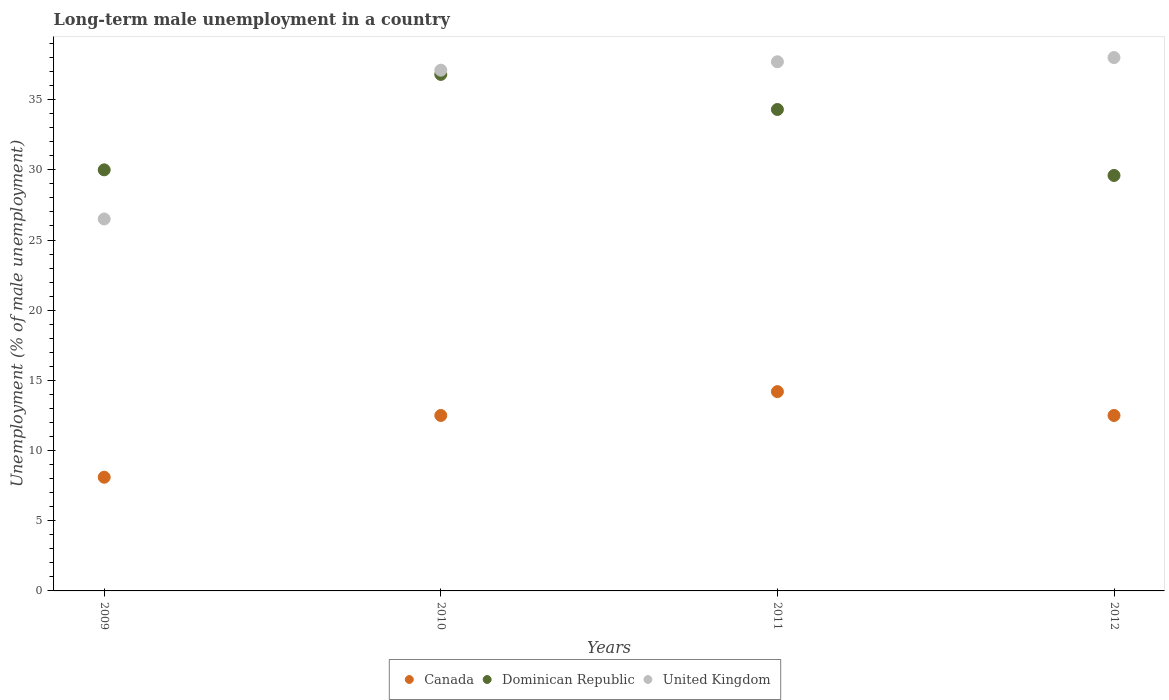How many different coloured dotlines are there?
Offer a very short reply. 3. Is the number of dotlines equal to the number of legend labels?
Provide a succinct answer. Yes. What is the percentage of long-term unemployed male population in Dominican Republic in 2011?
Keep it short and to the point. 34.3. Across all years, what is the minimum percentage of long-term unemployed male population in Dominican Republic?
Your answer should be very brief. 29.6. What is the total percentage of long-term unemployed male population in Dominican Republic in the graph?
Provide a short and direct response. 130.7. What is the difference between the percentage of long-term unemployed male population in Canada in 2009 and that in 2011?
Offer a very short reply. -6.1. What is the difference between the percentage of long-term unemployed male population in Dominican Republic in 2012 and the percentage of long-term unemployed male population in United Kingdom in 2009?
Offer a terse response. 3.1. What is the average percentage of long-term unemployed male population in Dominican Republic per year?
Your answer should be compact. 32.67. In the year 2012, what is the difference between the percentage of long-term unemployed male population in Dominican Republic and percentage of long-term unemployed male population in Canada?
Make the answer very short. 17.1. What is the ratio of the percentage of long-term unemployed male population in Canada in 2009 to that in 2011?
Provide a short and direct response. 0.57. Is the percentage of long-term unemployed male population in Dominican Republic in 2010 less than that in 2011?
Make the answer very short. No. What is the difference between the highest and the second highest percentage of long-term unemployed male population in Canada?
Keep it short and to the point. 1.7. What is the difference between the highest and the lowest percentage of long-term unemployed male population in United Kingdom?
Offer a terse response. 11.5. In how many years, is the percentage of long-term unemployed male population in United Kingdom greater than the average percentage of long-term unemployed male population in United Kingdom taken over all years?
Keep it short and to the point. 3. Is it the case that in every year, the sum of the percentage of long-term unemployed male population in Dominican Republic and percentage of long-term unemployed male population in Canada  is greater than the percentage of long-term unemployed male population in United Kingdom?
Your response must be concise. Yes. Does the percentage of long-term unemployed male population in Canada monotonically increase over the years?
Offer a very short reply. No. Is the percentage of long-term unemployed male population in Canada strictly greater than the percentage of long-term unemployed male population in Dominican Republic over the years?
Provide a succinct answer. No. Is the percentage of long-term unemployed male population in United Kingdom strictly less than the percentage of long-term unemployed male population in Canada over the years?
Make the answer very short. No. How many dotlines are there?
Ensure brevity in your answer.  3. How many years are there in the graph?
Offer a terse response. 4. What is the difference between two consecutive major ticks on the Y-axis?
Give a very brief answer. 5. Does the graph contain any zero values?
Ensure brevity in your answer.  No. Does the graph contain grids?
Provide a succinct answer. No. What is the title of the graph?
Offer a terse response. Long-term male unemployment in a country. Does "East Asia (all income levels)" appear as one of the legend labels in the graph?
Make the answer very short. No. What is the label or title of the Y-axis?
Keep it short and to the point. Unemployment (% of male unemployment). What is the Unemployment (% of male unemployment) of Canada in 2009?
Keep it short and to the point. 8.1. What is the Unemployment (% of male unemployment) in Dominican Republic in 2010?
Offer a terse response. 36.8. What is the Unemployment (% of male unemployment) of United Kingdom in 2010?
Make the answer very short. 37.1. What is the Unemployment (% of male unemployment) in Canada in 2011?
Your answer should be very brief. 14.2. What is the Unemployment (% of male unemployment) of Dominican Republic in 2011?
Make the answer very short. 34.3. What is the Unemployment (% of male unemployment) of United Kingdom in 2011?
Provide a short and direct response. 37.7. What is the Unemployment (% of male unemployment) of Canada in 2012?
Your answer should be very brief. 12.5. What is the Unemployment (% of male unemployment) in Dominican Republic in 2012?
Provide a short and direct response. 29.6. What is the Unemployment (% of male unemployment) in United Kingdom in 2012?
Provide a short and direct response. 38. Across all years, what is the maximum Unemployment (% of male unemployment) of Canada?
Your response must be concise. 14.2. Across all years, what is the maximum Unemployment (% of male unemployment) in Dominican Republic?
Your answer should be compact. 36.8. Across all years, what is the minimum Unemployment (% of male unemployment) of Canada?
Offer a very short reply. 8.1. Across all years, what is the minimum Unemployment (% of male unemployment) in Dominican Republic?
Your answer should be compact. 29.6. Across all years, what is the minimum Unemployment (% of male unemployment) of United Kingdom?
Offer a very short reply. 26.5. What is the total Unemployment (% of male unemployment) of Canada in the graph?
Your response must be concise. 47.3. What is the total Unemployment (% of male unemployment) of Dominican Republic in the graph?
Ensure brevity in your answer.  130.7. What is the total Unemployment (% of male unemployment) of United Kingdom in the graph?
Keep it short and to the point. 139.3. What is the difference between the Unemployment (% of male unemployment) in United Kingdom in 2009 and that in 2011?
Provide a short and direct response. -11.2. What is the difference between the Unemployment (% of male unemployment) in Dominican Republic in 2009 and that in 2012?
Give a very brief answer. 0.4. What is the difference between the Unemployment (% of male unemployment) in Dominican Republic in 2010 and that in 2011?
Offer a very short reply. 2.5. What is the difference between the Unemployment (% of male unemployment) in United Kingdom in 2010 and that in 2011?
Provide a succinct answer. -0.6. What is the difference between the Unemployment (% of male unemployment) in Canada in 2010 and that in 2012?
Provide a succinct answer. 0. What is the difference between the Unemployment (% of male unemployment) in Dominican Republic in 2010 and that in 2012?
Your answer should be compact. 7.2. What is the difference between the Unemployment (% of male unemployment) in Dominican Republic in 2011 and that in 2012?
Offer a terse response. 4.7. What is the difference between the Unemployment (% of male unemployment) of Canada in 2009 and the Unemployment (% of male unemployment) of Dominican Republic in 2010?
Your answer should be compact. -28.7. What is the difference between the Unemployment (% of male unemployment) in Canada in 2009 and the Unemployment (% of male unemployment) in Dominican Republic in 2011?
Your response must be concise. -26.2. What is the difference between the Unemployment (% of male unemployment) in Canada in 2009 and the Unemployment (% of male unemployment) in United Kingdom in 2011?
Provide a short and direct response. -29.6. What is the difference between the Unemployment (% of male unemployment) of Dominican Republic in 2009 and the Unemployment (% of male unemployment) of United Kingdom in 2011?
Give a very brief answer. -7.7. What is the difference between the Unemployment (% of male unemployment) in Canada in 2009 and the Unemployment (% of male unemployment) in Dominican Republic in 2012?
Your answer should be very brief. -21.5. What is the difference between the Unemployment (% of male unemployment) in Canada in 2009 and the Unemployment (% of male unemployment) in United Kingdom in 2012?
Give a very brief answer. -29.9. What is the difference between the Unemployment (% of male unemployment) of Canada in 2010 and the Unemployment (% of male unemployment) of Dominican Republic in 2011?
Your response must be concise. -21.8. What is the difference between the Unemployment (% of male unemployment) of Canada in 2010 and the Unemployment (% of male unemployment) of United Kingdom in 2011?
Ensure brevity in your answer.  -25.2. What is the difference between the Unemployment (% of male unemployment) in Canada in 2010 and the Unemployment (% of male unemployment) in Dominican Republic in 2012?
Keep it short and to the point. -17.1. What is the difference between the Unemployment (% of male unemployment) of Canada in 2010 and the Unemployment (% of male unemployment) of United Kingdom in 2012?
Ensure brevity in your answer.  -25.5. What is the difference between the Unemployment (% of male unemployment) of Canada in 2011 and the Unemployment (% of male unemployment) of Dominican Republic in 2012?
Provide a short and direct response. -15.4. What is the difference between the Unemployment (% of male unemployment) in Canada in 2011 and the Unemployment (% of male unemployment) in United Kingdom in 2012?
Your response must be concise. -23.8. What is the difference between the Unemployment (% of male unemployment) of Dominican Republic in 2011 and the Unemployment (% of male unemployment) of United Kingdom in 2012?
Your answer should be compact. -3.7. What is the average Unemployment (% of male unemployment) in Canada per year?
Keep it short and to the point. 11.82. What is the average Unemployment (% of male unemployment) of Dominican Republic per year?
Keep it short and to the point. 32.67. What is the average Unemployment (% of male unemployment) of United Kingdom per year?
Provide a short and direct response. 34.83. In the year 2009, what is the difference between the Unemployment (% of male unemployment) in Canada and Unemployment (% of male unemployment) in Dominican Republic?
Offer a very short reply. -21.9. In the year 2009, what is the difference between the Unemployment (% of male unemployment) in Canada and Unemployment (% of male unemployment) in United Kingdom?
Offer a very short reply. -18.4. In the year 2010, what is the difference between the Unemployment (% of male unemployment) in Canada and Unemployment (% of male unemployment) in Dominican Republic?
Your response must be concise. -24.3. In the year 2010, what is the difference between the Unemployment (% of male unemployment) of Canada and Unemployment (% of male unemployment) of United Kingdom?
Offer a very short reply. -24.6. In the year 2011, what is the difference between the Unemployment (% of male unemployment) in Canada and Unemployment (% of male unemployment) in Dominican Republic?
Offer a very short reply. -20.1. In the year 2011, what is the difference between the Unemployment (% of male unemployment) in Canada and Unemployment (% of male unemployment) in United Kingdom?
Provide a succinct answer. -23.5. In the year 2011, what is the difference between the Unemployment (% of male unemployment) in Dominican Republic and Unemployment (% of male unemployment) in United Kingdom?
Your answer should be compact. -3.4. In the year 2012, what is the difference between the Unemployment (% of male unemployment) of Canada and Unemployment (% of male unemployment) of Dominican Republic?
Your answer should be very brief. -17.1. In the year 2012, what is the difference between the Unemployment (% of male unemployment) of Canada and Unemployment (% of male unemployment) of United Kingdom?
Provide a succinct answer. -25.5. What is the ratio of the Unemployment (% of male unemployment) in Canada in 2009 to that in 2010?
Offer a very short reply. 0.65. What is the ratio of the Unemployment (% of male unemployment) in Dominican Republic in 2009 to that in 2010?
Offer a very short reply. 0.82. What is the ratio of the Unemployment (% of male unemployment) of Canada in 2009 to that in 2011?
Your response must be concise. 0.57. What is the ratio of the Unemployment (% of male unemployment) in Dominican Republic in 2009 to that in 2011?
Your answer should be very brief. 0.87. What is the ratio of the Unemployment (% of male unemployment) in United Kingdom in 2009 to that in 2011?
Offer a terse response. 0.7. What is the ratio of the Unemployment (% of male unemployment) in Canada in 2009 to that in 2012?
Make the answer very short. 0.65. What is the ratio of the Unemployment (% of male unemployment) in Dominican Republic in 2009 to that in 2012?
Your answer should be very brief. 1.01. What is the ratio of the Unemployment (% of male unemployment) of United Kingdom in 2009 to that in 2012?
Keep it short and to the point. 0.7. What is the ratio of the Unemployment (% of male unemployment) in Canada in 2010 to that in 2011?
Keep it short and to the point. 0.88. What is the ratio of the Unemployment (% of male unemployment) in Dominican Republic in 2010 to that in 2011?
Make the answer very short. 1.07. What is the ratio of the Unemployment (% of male unemployment) of United Kingdom in 2010 to that in 2011?
Your response must be concise. 0.98. What is the ratio of the Unemployment (% of male unemployment) of Dominican Republic in 2010 to that in 2012?
Your answer should be compact. 1.24. What is the ratio of the Unemployment (% of male unemployment) of United Kingdom in 2010 to that in 2012?
Offer a very short reply. 0.98. What is the ratio of the Unemployment (% of male unemployment) in Canada in 2011 to that in 2012?
Your answer should be very brief. 1.14. What is the ratio of the Unemployment (% of male unemployment) of Dominican Republic in 2011 to that in 2012?
Keep it short and to the point. 1.16. What is the difference between the highest and the second highest Unemployment (% of male unemployment) in Canada?
Keep it short and to the point. 1.7. What is the difference between the highest and the lowest Unemployment (% of male unemployment) of Canada?
Give a very brief answer. 6.1. What is the difference between the highest and the lowest Unemployment (% of male unemployment) of Dominican Republic?
Offer a very short reply. 7.2. 